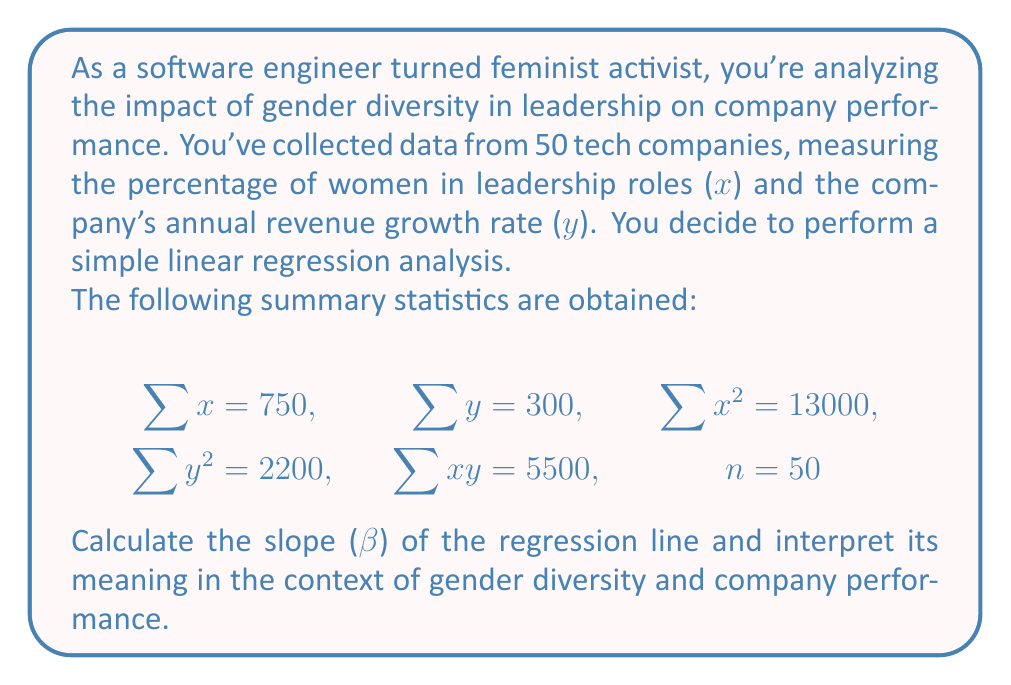Provide a solution to this math problem. To calculate the slope (β) of the regression line, we'll use the formula:

$$\beta = \frac{n\sum xy - \sum x \sum y}{n\sum x^2 - (\sum x)^2}$$

Let's substitute the given values:

$$\beta = \frac{50(5500) - (750)(300)}{50(13000) - (750)^2}$$

$$\beta = \frac{275000 - 225000}{650000 - 562500}$$

$$\beta = \frac{50000}{87500}$$

$$\beta = \frac{4}{7} \approx 0.5714$$

Interpretation:
The slope (β) represents the change in the company's annual revenue growth rate for each one percentage point increase in women in leadership roles. In this case, β ≈ 0.5714 means that for every 1 percentage point increase in women in leadership positions, the company's annual revenue growth rate tends to increase by approximately 0.5714 percentage points.

This positive slope suggests a positive relationship between gender diversity in leadership and company performance, supporting the argument for increased representation of women in leadership roles.
Answer: $\beta = \frac{4}{7} \approx 0.5714$ 